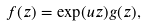<formula> <loc_0><loc_0><loc_500><loc_500>f ( z ) = \exp ( u z ) g ( z ) ,</formula> 